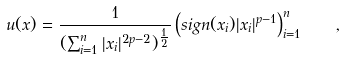Convert formula to latex. <formula><loc_0><loc_0><loc_500><loc_500>u ( x ) = \frac { 1 } { ( \sum _ { i = 1 } ^ { n } | x _ { i } | ^ { 2 p - 2 } ) ^ { \frac { 1 } { 2 } } } \left ( s i g n ( x _ { i } ) | x _ { i } | ^ { p - 1 } \right ) _ { i = 1 } ^ { n } \quad ,</formula> 